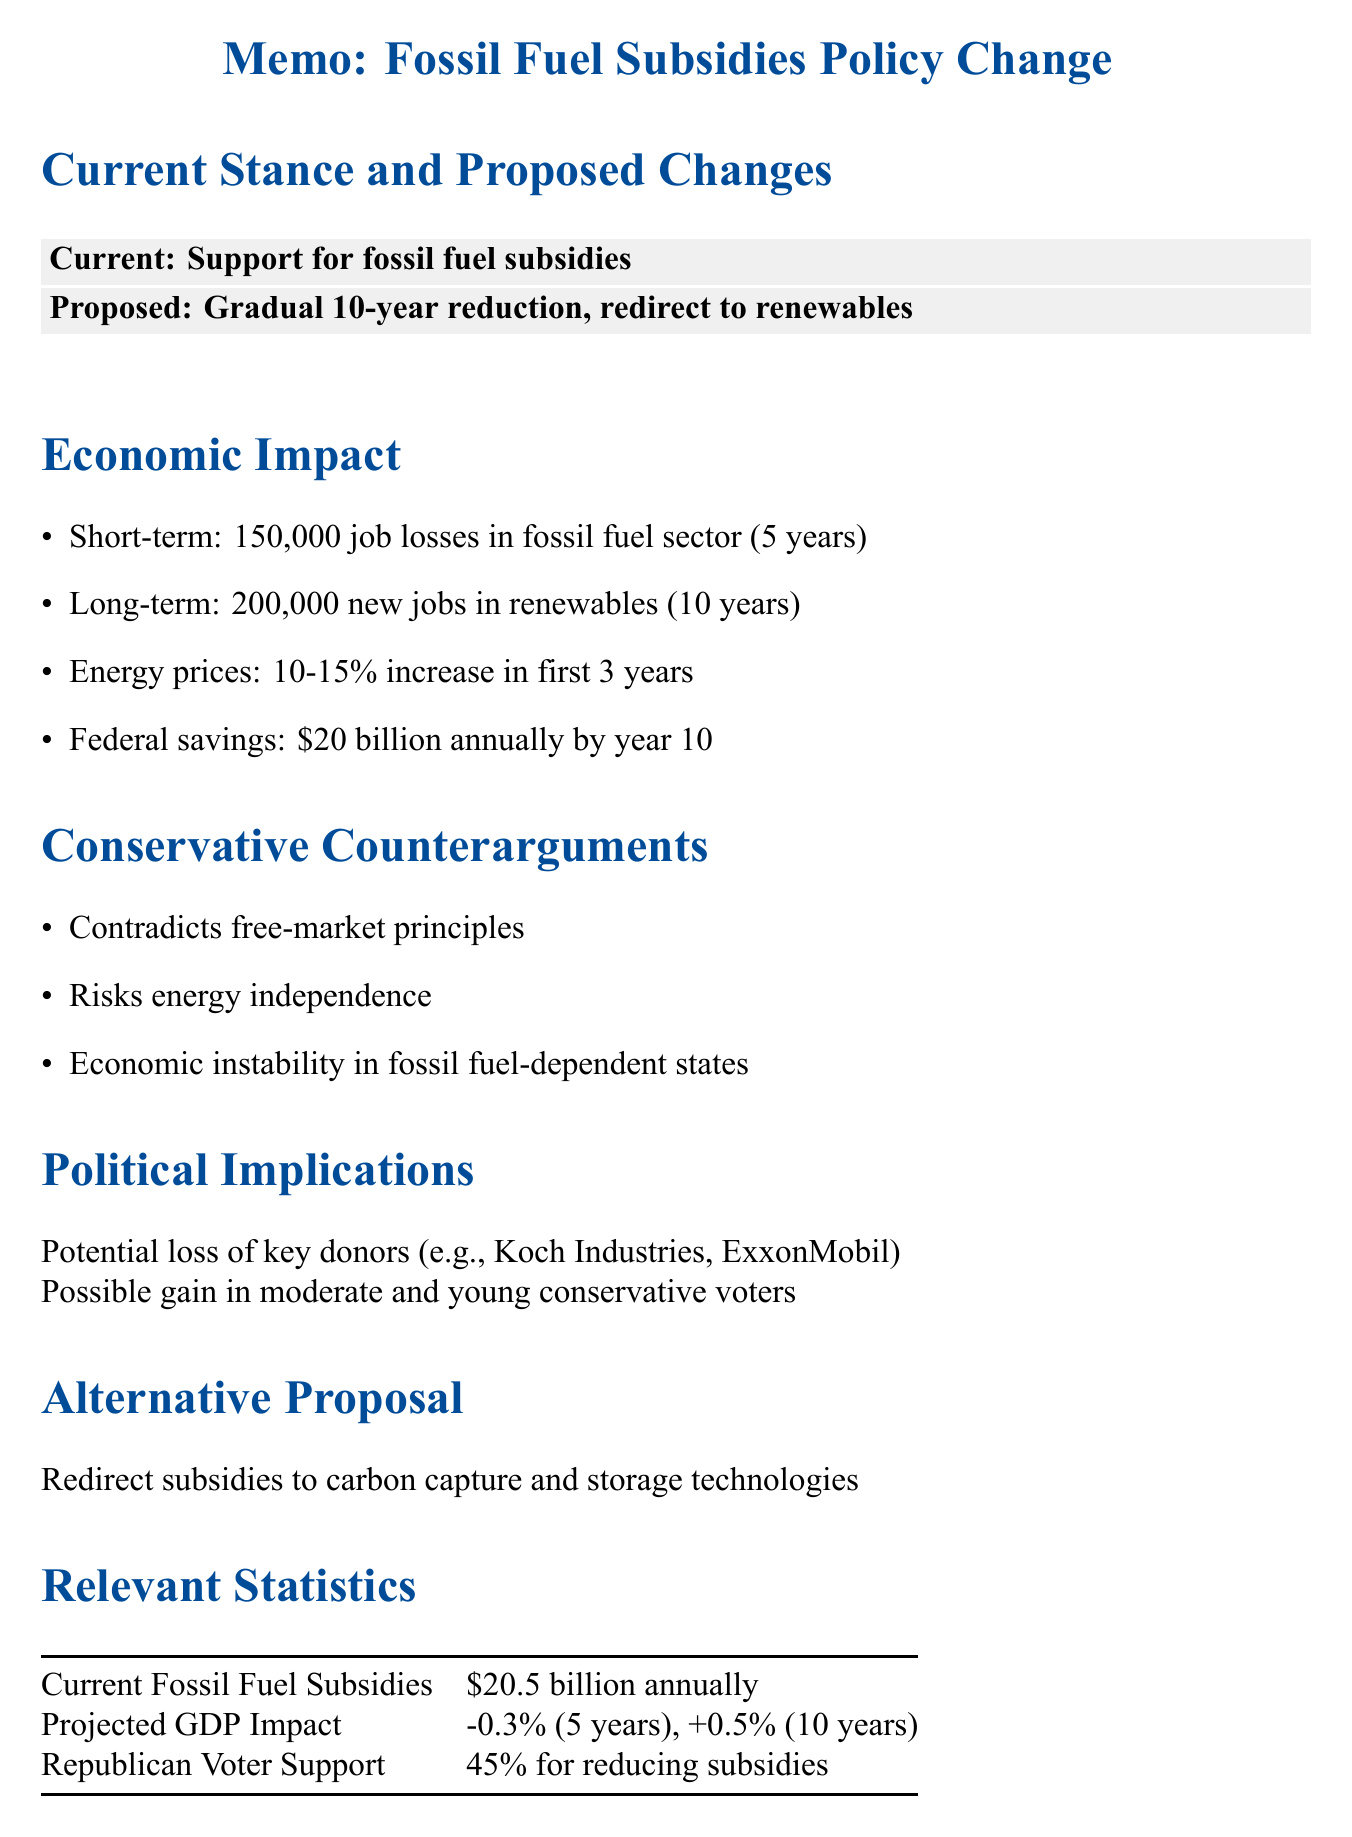What is the current annual amount of fossil fuel subsidies? The document states that current fossil fuel subsidies amount to $20.5 billion annually.
Answer: $20.5 billion annually How many jobs are projected to be lost in the fossil fuel sector short-term? The memo estimates that there will be 150,000 job losses in the fossil fuel sector over 5 years.
Answer: 150,000 What is the projected increase in energy prices for consumers? The document estimates an increase in energy prices for consumers at around 10-15% in the first 3 years.
Answer: 10-15% What are the proposed alternative solutions mentioned in the memo? The memo presents an alternative proposal to redirect subsidies to carbon capture and storage technologies.
Answer: Carbon capture and storage technologies What percentage of Republican voters support reducing fossil fuel subsidies? The document cites that 45% of Republican voters support reducing fossil fuel subsidies.
Answer: 45% What is the potential long-term job creation in the renewable energy sector? The memo projects long-term job creation in the renewable energy sector at 200,000 jobs over 10 years.
Answer: 200,000 What is a significant risk mentioned for fossil fuel-dependent states? The document notes that there is a risk of economic instability in fossil fuel-dependent states like Texas and North Dakota.
Answer: Economic instability What economic impact is projected for the GDP in the first five years? The document states a projected GDP impact of a 0.3% decrease in the first 5 years.
Answer: 0.3% decrease Which expert argues against cutting fossil fuel subsidies? The document mentions Stephen Moore from the Heritage Foundation as arguing against cutting fossil fuel subsidies.
Answer: Stephen Moore 